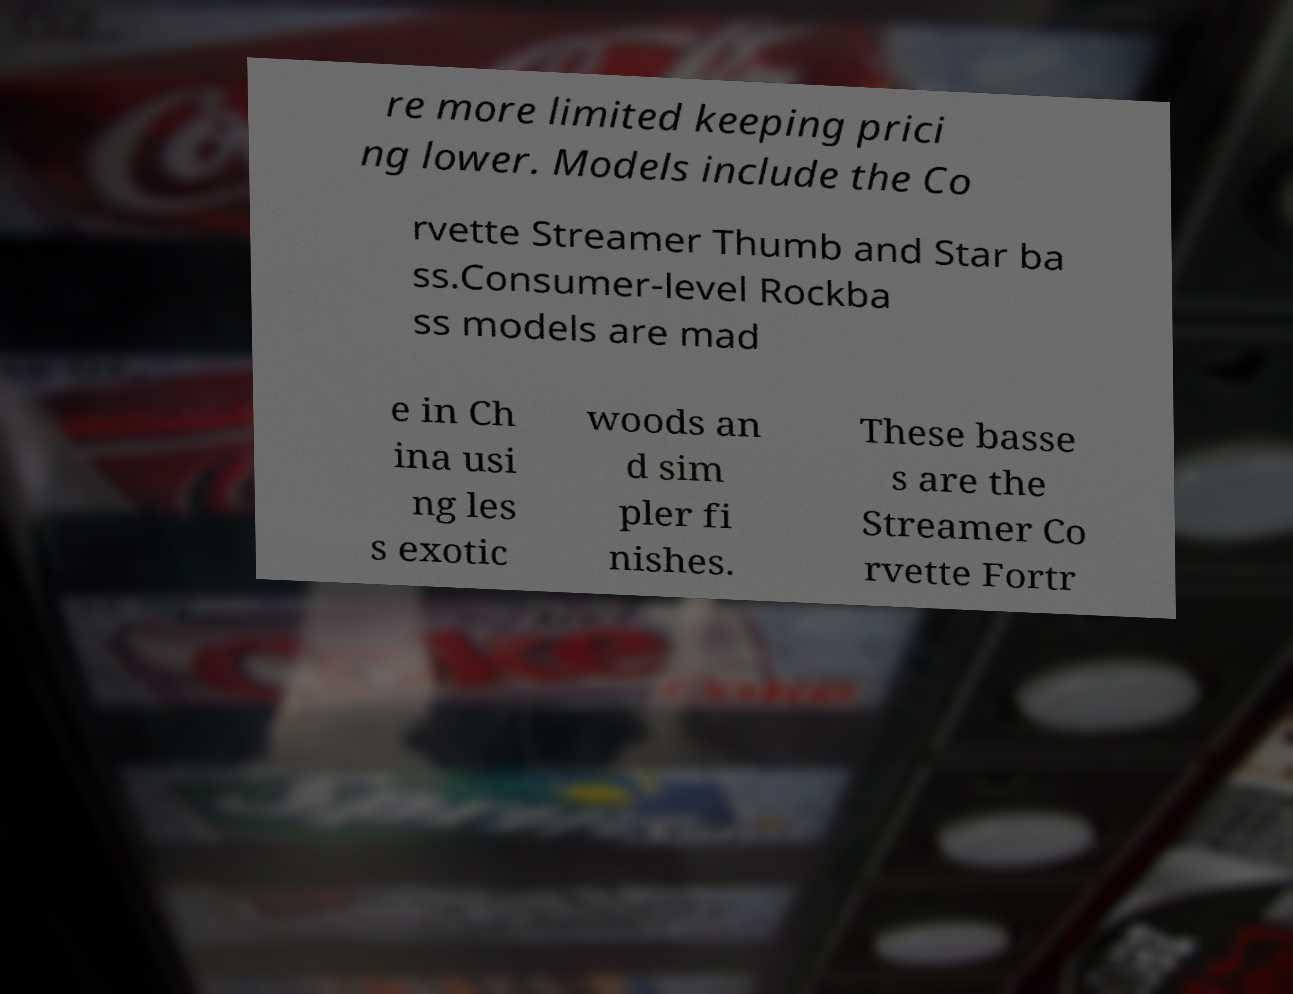Please identify and transcribe the text found in this image. re more limited keeping prici ng lower. Models include the Co rvette Streamer Thumb and Star ba ss.Consumer-level Rockba ss models are mad e in Ch ina usi ng les s exotic woods an d sim pler fi nishes. These basse s are the Streamer Co rvette Fortr 